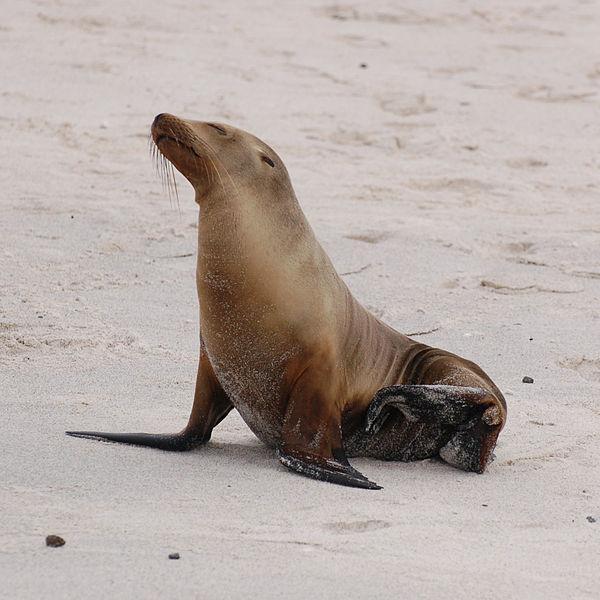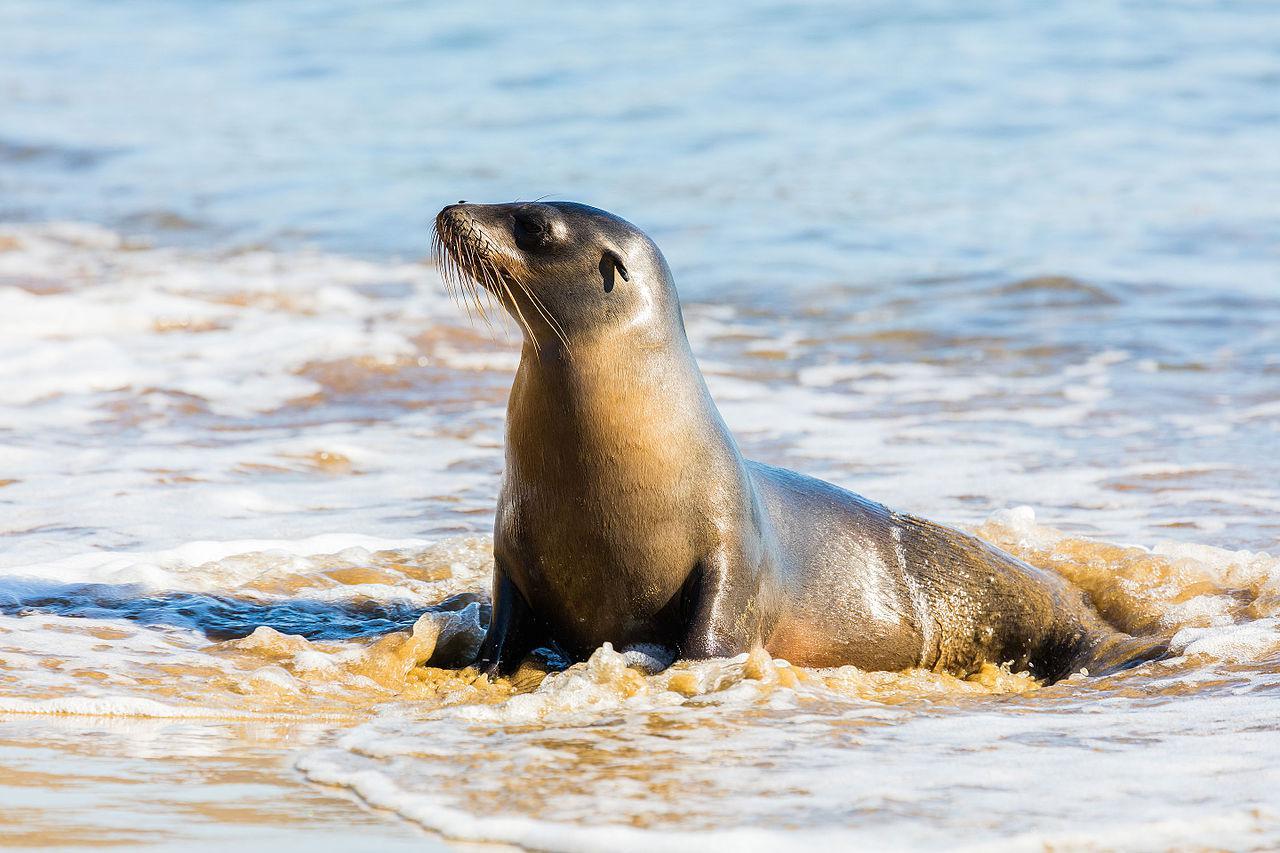The first image is the image on the left, the second image is the image on the right. Evaluate the accuracy of this statement regarding the images: "An image shows a seal with body in profile and water visible.". Is it true? Answer yes or no. Yes. The first image is the image on the left, the second image is the image on the right. Analyze the images presented: Is the assertion "There is 1 seal near waves on a sunny day." valid? Answer yes or no. Yes. 